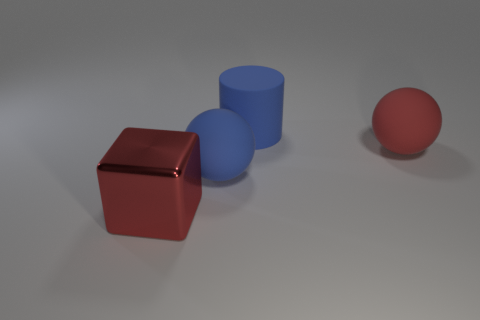What number of red objects have the same material as the blue cylinder?
Make the answer very short. 1. What material is the large blue cylinder?
Provide a succinct answer. Rubber. There is a big blue object in front of the red object behind the cube; what shape is it?
Ensure brevity in your answer.  Sphere. The big object right of the large blue rubber cylinder has what shape?
Your answer should be compact. Sphere. What number of other large cylinders have the same color as the big cylinder?
Ensure brevity in your answer.  0. The large metallic cube has what color?
Make the answer very short. Red. What number of blue cylinders are in front of the ball that is behind the blue sphere?
Your answer should be compact. 0. There is a red matte sphere; does it have the same size as the blue rubber object in front of the red sphere?
Ensure brevity in your answer.  Yes. Does the matte cylinder have the same size as the red block?
Your answer should be very brief. Yes. Is there a shiny cylinder that has the same size as the red cube?
Your response must be concise. No. 